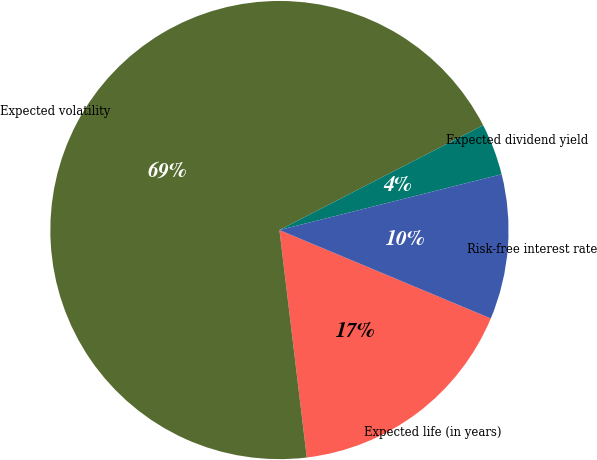Convert chart. <chart><loc_0><loc_0><loc_500><loc_500><pie_chart><fcel>Expected life (in years)<fcel>Expected volatility<fcel>Expected dividend yield<fcel>Risk-free interest rate<nl><fcel>16.79%<fcel>69.34%<fcel>3.65%<fcel>10.22%<nl></chart> 